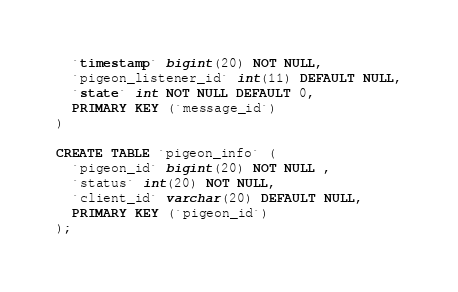Convert code to text. <code><loc_0><loc_0><loc_500><loc_500><_SQL_>  `timestamp` bigint(20) NOT NULL,
  `pigeon_listener_id` int(11) DEFAULT NULL,
  `state` int NOT NULL DEFAULT 0,
  PRIMARY KEY (`message_id`)
) 

CREATE TABLE `pigeon_info` (
  `pigeon_id` bigint(20) NOT NULL ,
  `status` int(20) NOT NULL,
  `client_id` varchar(20) DEFAULT NULL,
  PRIMARY KEY (`pigeon_id`)
);</code> 